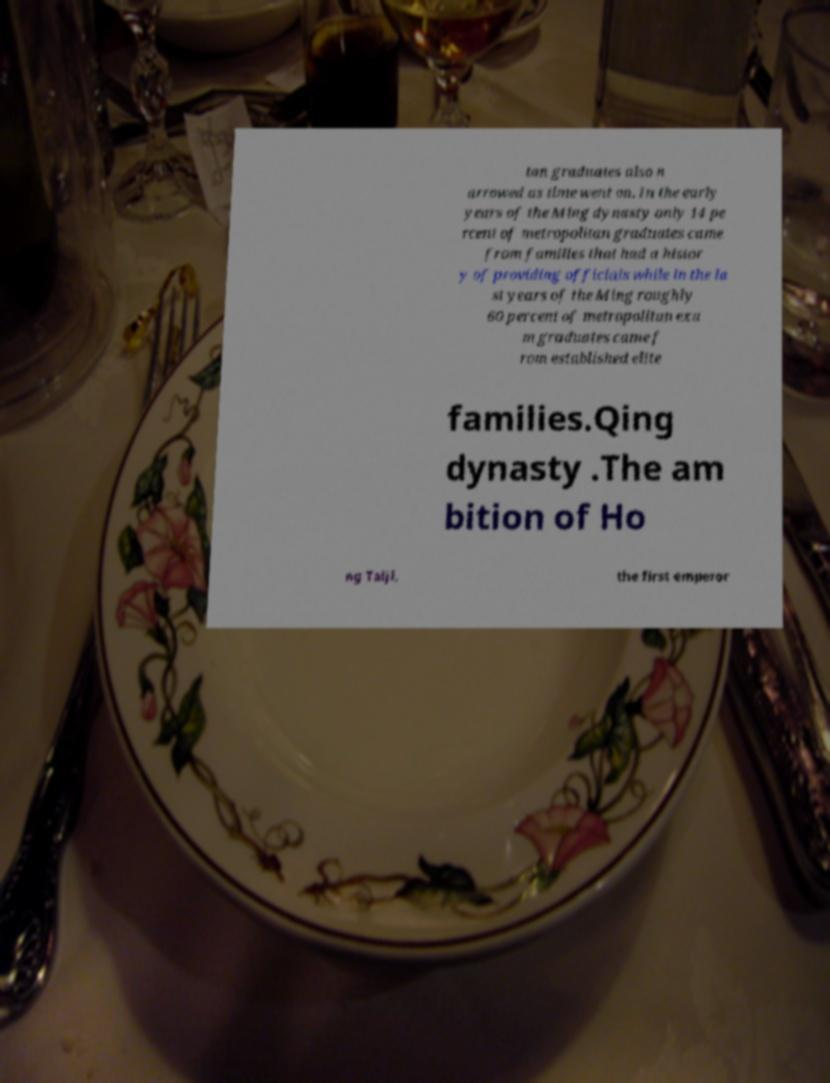Can you accurately transcribe the text from the provided image for me? tan graduates also n arrowed as time went on. In the early years of the Ming dynasty only 14 pe rcent of metropolitan graduates came from families that had a histor y of providing officials while in the la st years of the Ming roughly 60 percent of metropolitan exa m graduates came f rom established elite families.Qing dynasty .The am bition of Ho ng Taiji, the first emperor 